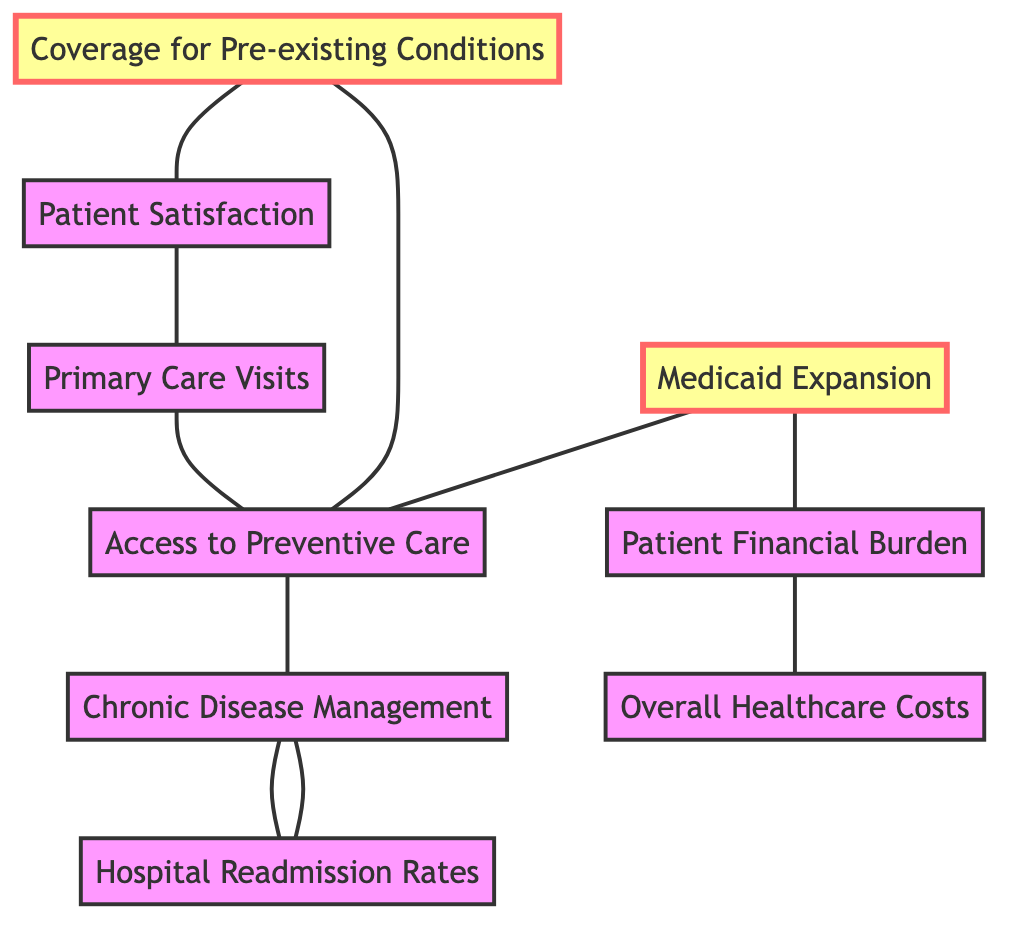What is the total number of nodes in the diagram? The diagram contains a total of nine nodes, which are Medicaid Expansion, Access to Preventive Care, Coverage for Pre-existing Conditions, Patient Satisfaction, Hospital Readmission Rates, Patient Financial Burden, Chronic Disease Management, Primary Care Visits, and Overall Healthcare Costs.
Answer: Nine Which two nodes are directly connected to Medicaid Expansion? According to the diagram, Medicaid Expansion is directly connected to Access to Preventive Care and Patient Financial Burden. This can be seen by following the edges that start from the Medicaid Expansion node.
Answer: Access to Preventive Care and Patient Financial Burden What node is connected to both Patient Satisfaction and Primary Care Visits? The node connected to both Patient Satisfaction and Primary Care Visits is directed through an edge that leads to Primary Care Visits from Patient Satisfaction. Therefore, the answer is Patient Satisfaction.
Answer: Patient Satisfaction How many edges are connected to the node Chronic Disease Management? Chronic Disease Management is connected to three edges, leading to Readmission Rates, Preventive Care Access, and Patient Satisfaction as seen through the respective connections in the diagram.
Answer: Three Which initiative is linked to both Financial Burden and Overall Healthcare Costs? Financial Burden is linked to Overall Healthcare Costs, indicating that changes in patient financial burden have a direct relationship with the overall costs of healthcare as represented in the diagram.
Answer: Overall Healthcare Costs How does Preventive Care Access impact Chronic Disease Management? Preventive Care Access positively impacts Chronic Disease Management through a direct edge that indicates a connection. This suggests that greater access to preventive care may lead to better management of chronic diseases.
Answer: Positive impact What is the relationship between Readmission Rates and Chronic Disease Management? The relationship between Readmission Rates and Chronic Disease Management is a direct connection, where an increase in Chronic Disease Management efforts is correlated with reduced Readmission Rates.
Answer: Direct connection Which node represents the coverage category for individuals with existing conditions? The node that represents the coverage category for individuals with existing conditions is Coverage for Pre-existing Conditions, showing that this aspect of Obamacare allowed better coverage for those individuals.
Answer: Coverage for Pre-existing Conditions 